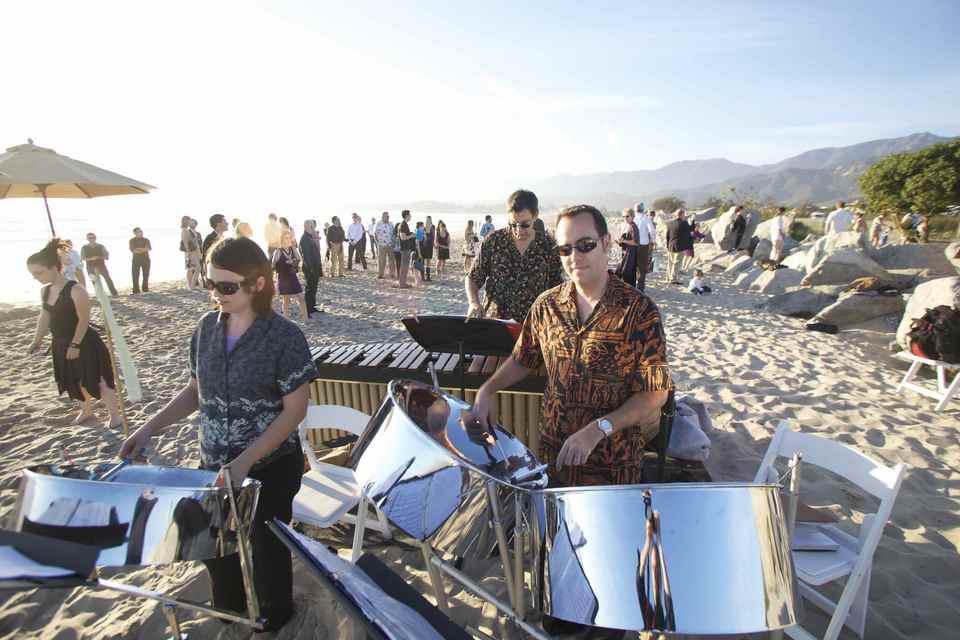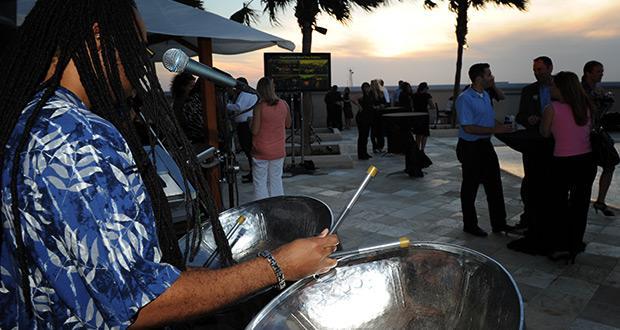The first image is the image on the left, the second image is the image on the right. Assess this claim about the two images: "The drummer in the image on the right is wearing a blue and white shirt.". Correct or not? Answer yes or no. Yes. The first image is the image on the left, the second image is the image on the right. Given the left and right images, does the statement "One man with long braids wearing a blue hawaiian shirt is playing stainless steel bowl-shaped drums in the right image." hold true? Answer yes or no. Yes. 